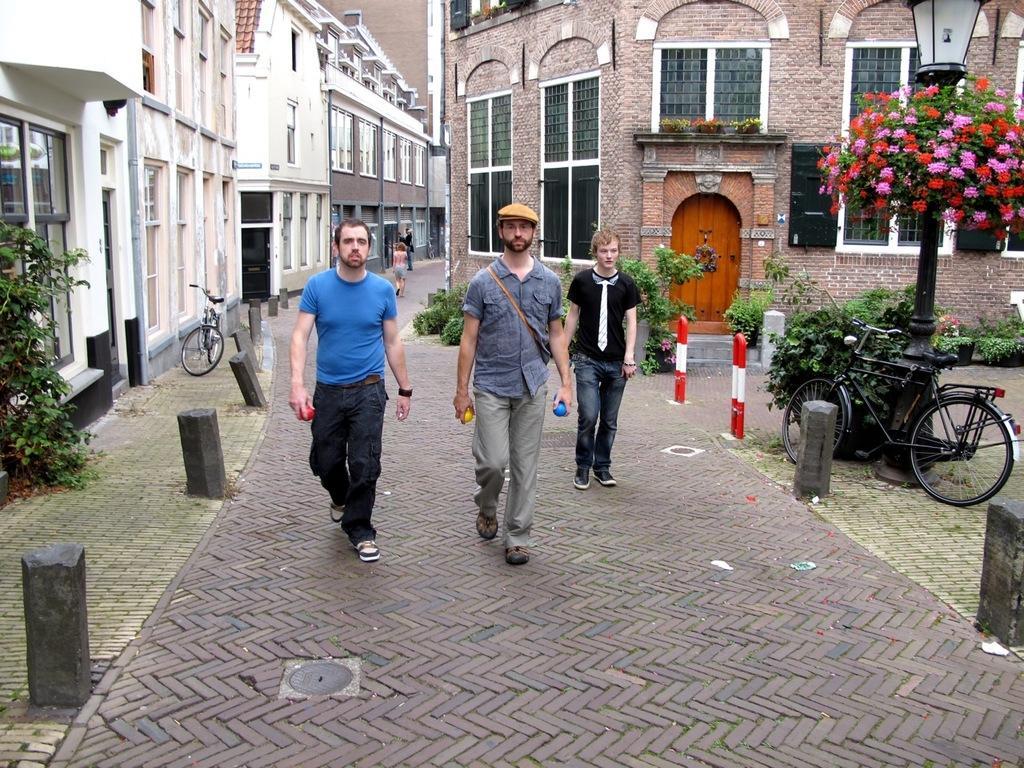How would you summarize this image in a sentence or two? In this image people are walking on the path. Middle of the image there is a person wearing a cap. He is holding objects in his hands. Right side there is a bicycle. Behind there is a street light. Behind there are plants. Right side there is a plant having flowers. Left side there is a plant and a bicycle on the path. Background there are buildings. 